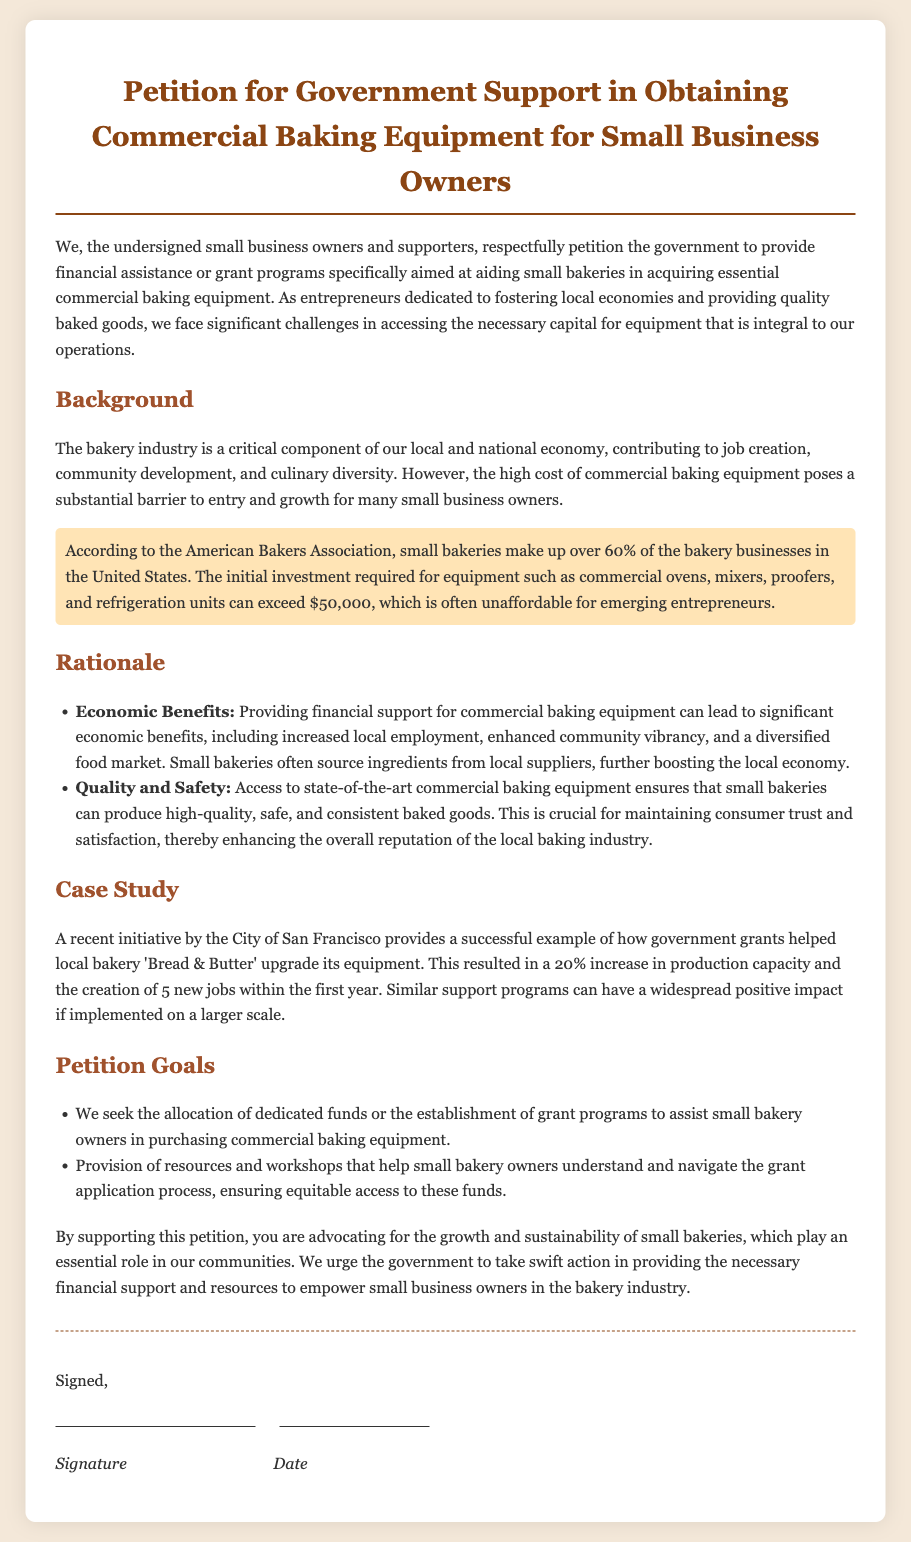What is the main purpose of the petition? The petition seeks to request financial assistance or grant programs for small bakeries to acquire commercial baking equipment.
Answer: financial assistance How much can the initial investment for commercial baking equipment exceed? The document states that the initial investment required for equipment can exceed $50,000.
Answer: $50,000 What percentage of bakery businesses in the United States are small bakeries? According to the document, small bakeries make up over 60% of bakery businesses in the United States.
Answer: over 60% Which city is mentioned as having a successful initiative in supporting bakeries? The document provides a case study on San Francisco's initiative to support local bakeries.
Answer: San Francisco What was the increase in production capacity for the 'Bread & Butter' bakery after government support? The government grants helped 'Bread & Butter' increase its production capacity by 20%.
Answer: 20% What are two goals of the petition? The two goals include seeking allocation of funds for small bakery owners and provision of resources for navigating grant applications.
Answer: allocation of funds; provision of resources What kind of equipment does the petition focus on? The petition focuses on essential commercial baking equipment necessary for bakeries.
Answer: commercial baking equipment What type of support is being requested for small bakery owners? The document requests financial support or grant programs for small bakery owners.
Answer: financial support 